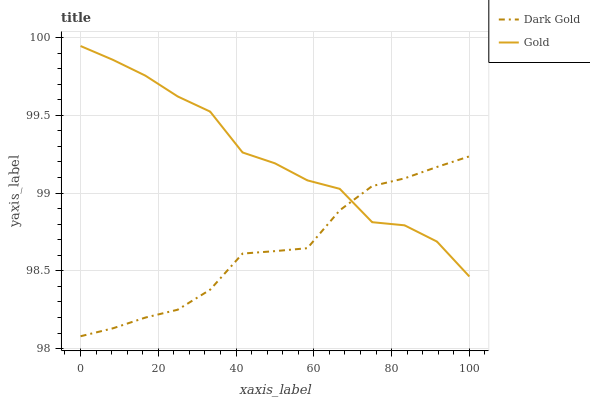Does Dark Gold have the minimum area under the curve?
Answer yes or no. Yes. Does Gold have the maximum area under the curve?
Answer yes or no. Yes. Does Dark Gold have the maximum area under the curve?
Answer yes or no. No. Is Dark Gold the smoothest?
Answer yes or no. Yes. Is Gold the roughest?
Answer yes or no. Yes. Is Dark Gold the roughest?
Answer yes or no. No. Does Dark Gold have the lowest value?
Answer yes or no. Yes. Does Gold have the highest value?
Answer yes or no. Yes. Does Dark Gold have the highest value?
Answer yes or no. No. Does Gold intersect Dark Gold?
Answer yes or no. Yes. Is Gold less than Dark Gold?
Answer yes or no. No. Is Gold greater than Dark Gold?
Answer yes or no. No. 